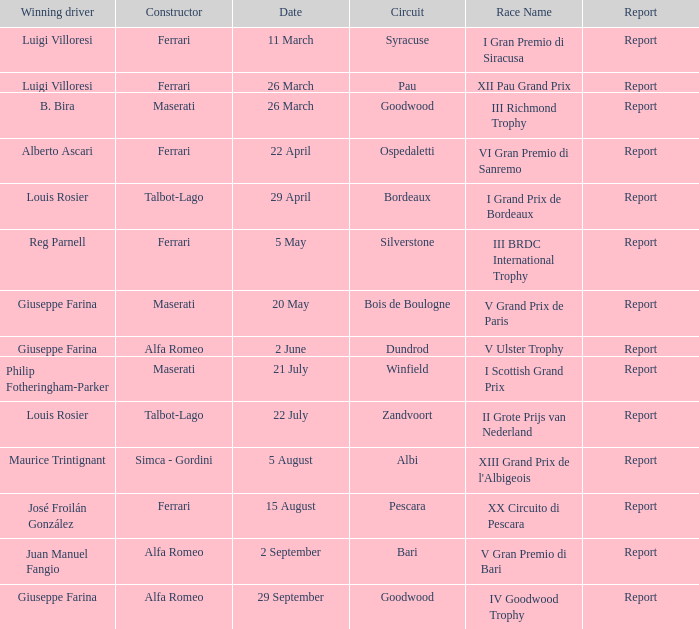Name the report on 20 may Report. 